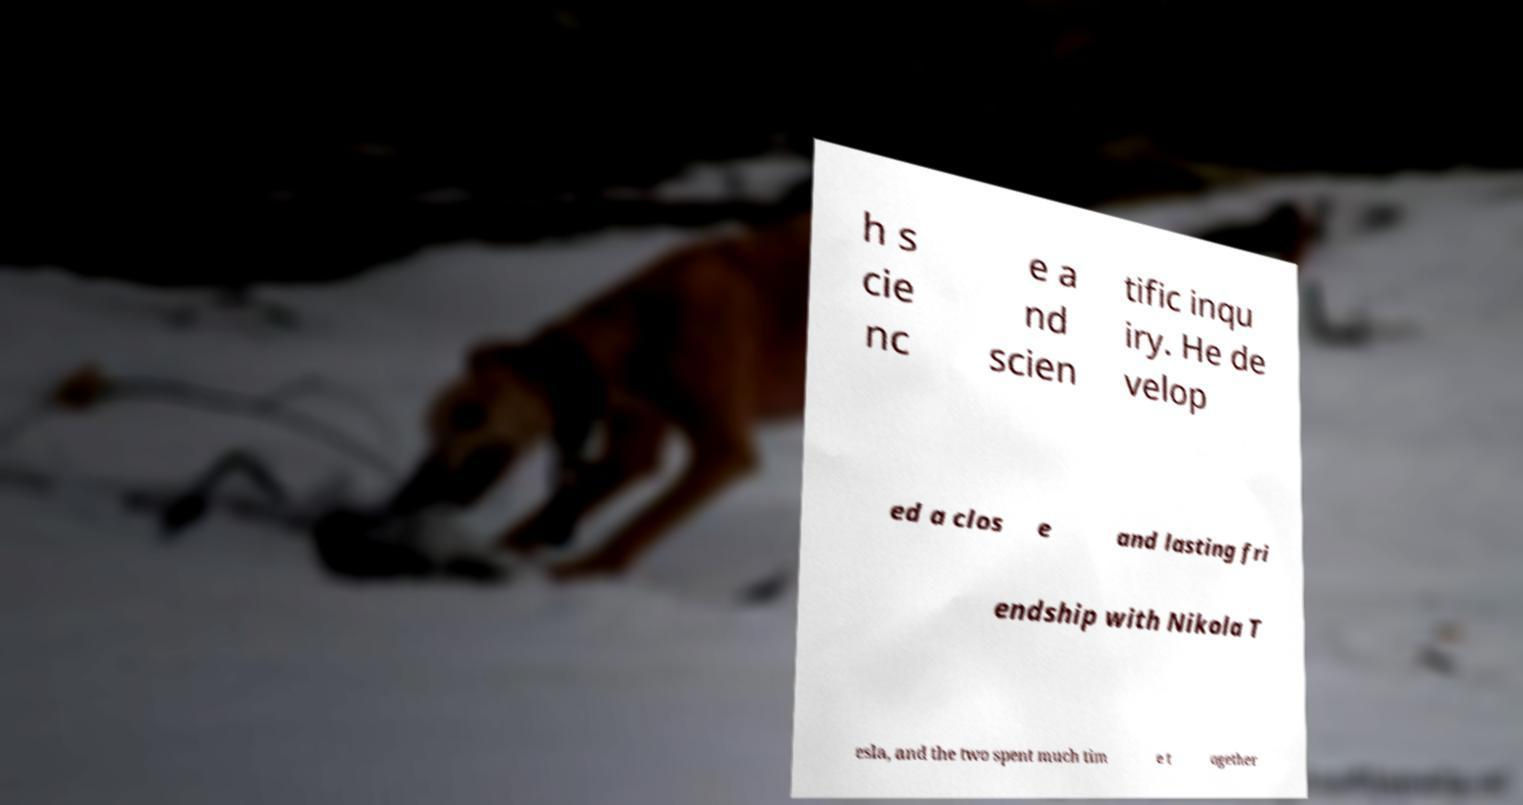Could you extract and type out the text from this image? h s cie nc e a nd scien tific inqu iry. He de velop ed a clos e and lasting fri endship with Nikola T esla, and the two spent much tim e t ogether 